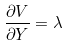<formula> <loc_0><loc_0><loc_500><loc_500>\frac { \partial V } { \partial Y } = \lambda</formula> 